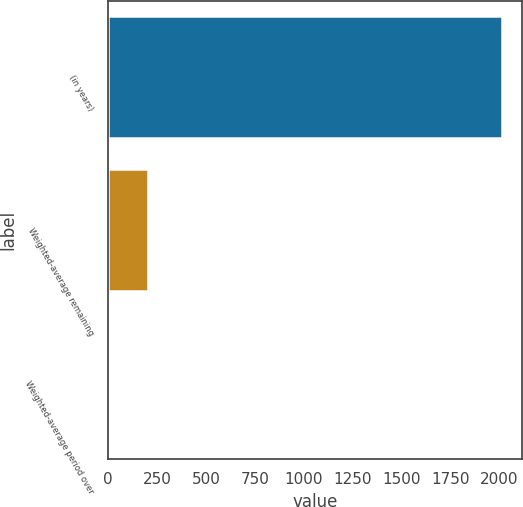Convert chart. <chart><loc_0><loc_0><loc_500><loc_500><bar_chart><fcel>(in years)<fcel>Weighted-average remaining<fcel>Weighted-average period over<nl><fcel>2016<fcel>203.4<fcel>2<nl></chart> 